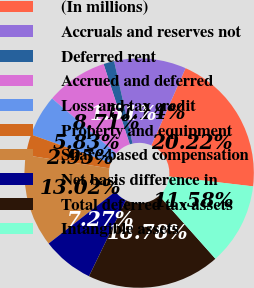Convert chart to OTSL. <chart><loc_0><loc_0><loc_500><loc_500><pie_chart><fcel>(In millions)<fcel>Accruals and reserves not<fcel>Deferred rent<fcel>Accrued and deferred<fcel>Loss and tax credit<fcel>Property and equipment<fcel>Share-based compensation<fcel>Net basis difference in<fcel>Total deferred tax assets<fcel>Intangible assets<nl><fcel>20.22%<fcel>10.14%<fcel>1.51%<fcel>8.71%<fcel>5.83%<fcel>2.95%<fcel>13.02%<fcel>7.27%<fcel>18.78%<fcel>11.58%<nl></chart> 